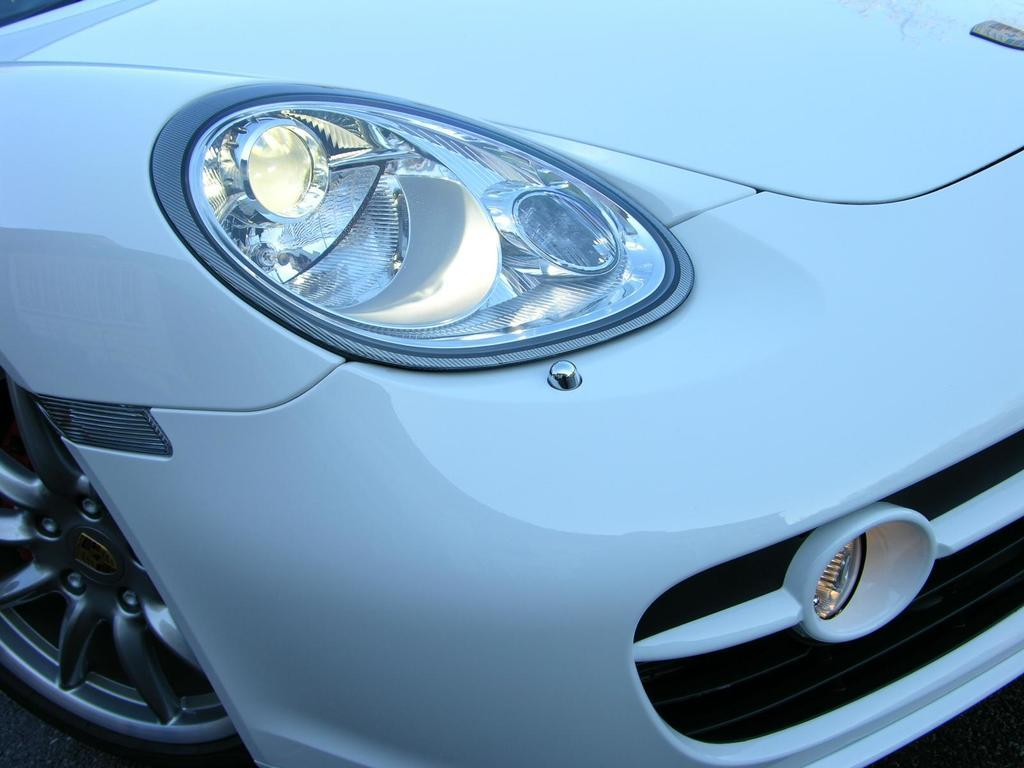What is the main subject of the image? The main subject of the image is a vehicle. What specific features can be seen on the vehicle? The vehicle has headlights and wheels. What type of verse can be seen written on the side of the vehicle in the image? There is no verse visible on the vehicle in the image. Where might the people inside the vehicle be eating their lunch in the image? There is no indication of people eating lunch inside the vehicle in the image. What type of planet is the vehicle driving on in the image? The image does not provide information about the planet the vehicle is driving on. 